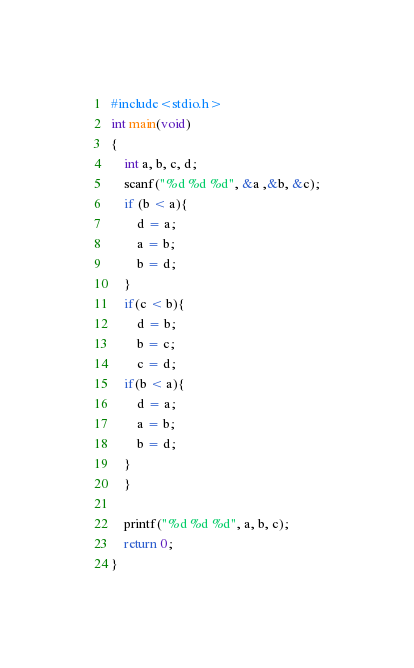<code> <loc_0><loc_0><loc_500><loc_500><_C_>#include<stdio.h>
int main(void)
{
	int a, b, c, d;
	scanf("%d %d %d", &a ,&b, &c);
	if (b < a){
		d = a;
		a = b;
		b = d;
	}
	if(c < b){
		d = b;
		b = c;
		c = d; 
	if(b < a){
		d = a;
		a = b;
		b = d;
	}
	}

	printf("%d %d %d", a, b, c);
	return 0;
}</code> 